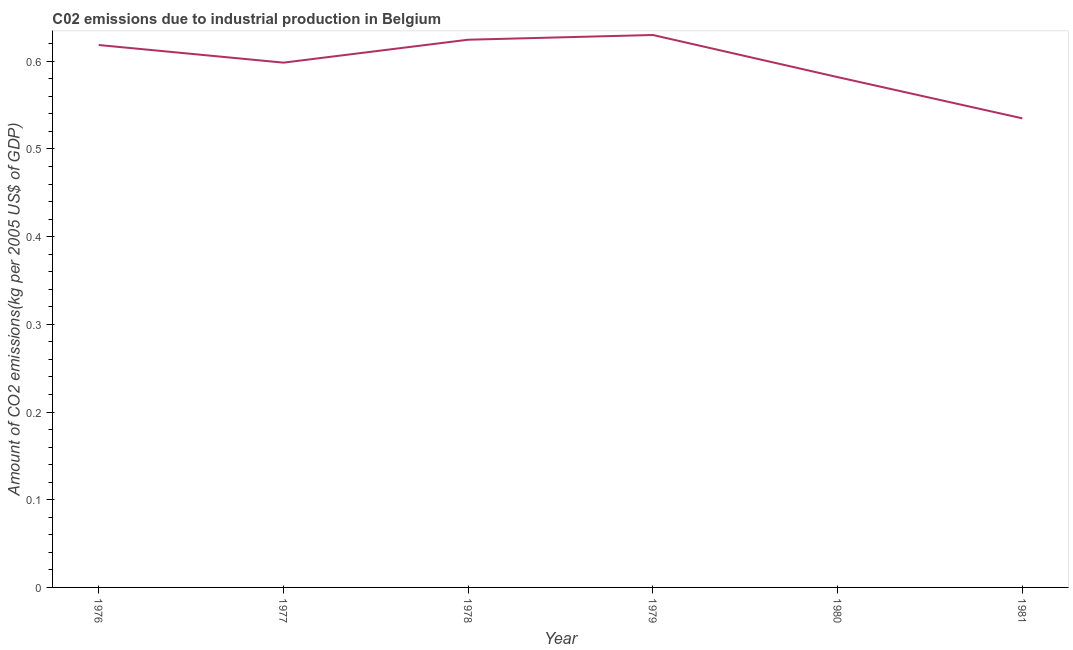What is the amount of co2 emissions in 1978?
Offer a very short reply. 0.62. Across all years, what is the maximum amount of co2 emissions?
Provide a short and direct response. 0.63. Across all years, what is the minimum amount of co2 emissions?
Offer a very short reply. 0.53. In which year was the amount of co2 emissions maximum?
Provide a short and direct response. 1979. What is the sum of the amount of co2 emissions?
Make the answer very short. 3.59. What is the difference between the amount of co2 emissions in 1979 and 1980?
Ensure brevity in your answer.  0.05. What is the average amount of co2 emissions per year?
Give a very brief answer. 0.6. What is the median amount of co2 emissions?
Your answer should be very brief. 0.61. In how many years, is the amount of co2 emissions greater than 0.26 kg per 2005 US$ of GDP?
Give a very brief answer. 6. Do a majority of the years between 1979 and 1976 (inclusive) have amount of co2 emissions greater than 0.5 kg per 2005 US$ of GDP?
Give a very brief answer. Yes. What is the ratio of the amount of co2 emissions in 1977 to that in 1978?
Provide a short and direct response. 0.96. Is the amount of co2 emissions in 1976 less than that in 1977?
Provide a short and direct response. No. Is the difference between the amount of co2 emissions in 1976 and 1980 greater than the difference between any two years?
Provide a succinct answer. No. What is the difference between the highest and the second highest amount of co2 emissions?
Offer a terse response. 0.01. Is the sum of the amount of co2 emissions in 1978 and 1980 greater than the maximum amount of co2 emissions across all years?
Make the answer very short. Yes. What is the difference between the highest and the lowest amount of co2 emissions?
Ensure brevity in your answer.  0.1. In how many years, is the amount of co2 emissions greater than the average amount of co2 emissions taken over all years?
Your answer should be compact. 4. Does the amount of co2 emissions monotonically increase over the years?
Provide a succinct answer. No. How many lines are there?
Offer a very short reply. 1. What is the difference between two consecutive major ticks on the Y-axis?
Provide a short and direct response. 0.1. Does the graph contain any zero values?
Give a very brief answer. No. Does the graph contain grids?
Ensure brevity in your answer.  No. What is the title of the graph?
Your answer should be compact. C02 emissions due to industrial production in Belgium. What is the label or title of the Y-axis?
Offer a terse response. Amount of CO2 emissions(kg per 2005 US$ of GDP). What is the Amount of CO2 emissions(kg per 2005 US$ of GDP) of 1976?
Your answer should be very brief. 0.62. What is the Amount of CO2 emissions(kg per 2005 US$ of GDP) of 1977?
Your answer should be compact. 0.6. What is the Amount of CO2 emissions(kg per 2005 US$ of GDP) in 1978?
Offer a terse response. 0.62. What is the Amount of CO2 emissions(kg per 2005 US$ of GDP) in 1979?
Your response must be concise. 0.63. What is the Amount of CO2 emissions(kg per 2005 US$ of GDP) of 1980?
Provide a succinct answer. 0.58. What is the Amount of CO2 emissions(kg per 2005 US$ of GDP) of 1981?
Offer a very short reply. 0.53. What is the difference between the Amount of CO2 emissions(kg per 2005 US$ of GDP) in 1976 and 1977?
Ensure brevity in your answer.  0.02. What is the difference between the Amount of CO2 emissions(kg per 2005 US$ of GDP) in 1976 and 1978?
Offer a terse response. -0.01. What is the difference between the Amount of CO2 emissions(kg per 2005 US$ of GDP) in 1976 and 1979?
Provide a succinct answer. -0.01. What is the difference between the Amount of CO2 emissions(kg per 2005 US$ of GDP) in 1976 and 1980?
Ensure brevity in your answer.  0.04. What is the difference between the Amount of CO2 emissions(kg per 2005 US$ of GDP) in 1976 and 1981?
Give a very brief answer. 0.08. What is the difference between the Amount of CO2 emissions(kg per 2005 US$ of GDP) in 1977 and 1978?
Keep it short and to the point. -0.03. What is the difference between the Amount of CO2 emissions(kg per 2005 US$ of GDP) in 1977 and 1979?
Ensure brevity in your answer.  -0.03. What is the difference between the Amount of CO2 emissions(kg per 2005 US$ of GDP) in 1977 and 1980?
Your response must be concise. 0.02. What is the difference between the Amount of CO2 emissions(kg per 2005 US$ of GDP) in 1977 and 1981?
Provide a short and direct response. 0.06. What is the difference between the Amount of CO2 emissions(kg per 2005 US$ of GDP) in 1978 and 1979?
Your answer should be very brief. -0.01. What is the difference between the Amount of CO2 emissions(kg per 2005 US$ of GDP) in 1978 and 1980?
Ensure brevity in your answer.  0.04. What is the difference between the Amount of CO2 emissions(kg per 2005 US$ of GDP) in 1978 and 1981?
Your answer should be compact. 0.09. What is the difference between the Amount of CO2 emissions(kg per 2005 US$ of GDP) in 1979 and 1980?
Make the answer very short. 0.05. What is the difference between the Amount of CO2 emissions(kg per 2005 US$ of GDP) in 1979 and 1981?
Offer a terse response. 0.1. What is the difference between the Amount of CO2 emissions(kg per 2005 US$ of GDP) in 1980 and 1981?
Ensure brevity in your answer.  0.05. What is the ratio of the Amount of CO2 emissions(kg per 2005 US$ of GDP) in 1976 to that in 1977?
Provide a short and direct response. 1.03. What is the ratio of the Amount of CO2 emissions(kg per 2005 US$ of GDP) in 1976 to that in 1978?
Give a very brief answer. 0.99. What is the ratio of the Amount of CO2 emissions(kg per 2005 US$ of GDP) in 1976 to that in 1980?
Offer a very short reply. 1.06. What is the ratio of the Amount of CO2 emissions(kg per 2005 US$ of GDP) in 1976 to that in 1981?
Your response must be concise. 1.16. What is the ratio of the Amount of CO2 emissions(kg per 2005 US$ of GDP) in 1977 to that in 1978?
Your answer should be very brief. 0.96. What is the ratio of the Amount of CO2 emissions(kg per 2005 US$ of GDP) in 1977 to that in 1979?
Offer a very short reply. 0.95. What is the ratio of the Amount of CO2 emissions(kg per 2005 US$ of GDP) in 1977 to that in 1980?
Your answer should be very brief. 1.03. What is the ratio of the Amount of CO2 emissions(kg per 2005 US$ of GDP) in 1977 to that in 1981?
Give a very brief answer. 1.12. What is the ratio of the Amount of CO2 emissions(kg per 2005 US$ of GDP) in 1978 to that in 1979?
Give a very brief answer. 0.99. What is the ratio of the Amount of CO2 emissions(kg per 2005 US$ of GDP) in 1978 to that in 1980?
Your answer should be very brief. 1.07. What is the ratio of the Amount of CO2 emissions(kg per 2005 US$ of GDP) in 1978 to that in 1981?
Offer a terse response. 1.17. What is the ratio of the Amount of CO2 emissions(kg per 2005 US$ of GDP) in 1979 to that in 1980?
Keep it short and to the point. 1.08. What is the ratio of the Amount of CO2 emissions(kg per 2005 US$ of GDP) in 1979 to that in 1981?
Make the answer very short. 1.18. What is the ratio of the Amount of CO2 emissions(kg per 2005 US$ of GDP) in 1980 to that in 1981?
Offer a terse response. 1.09. 